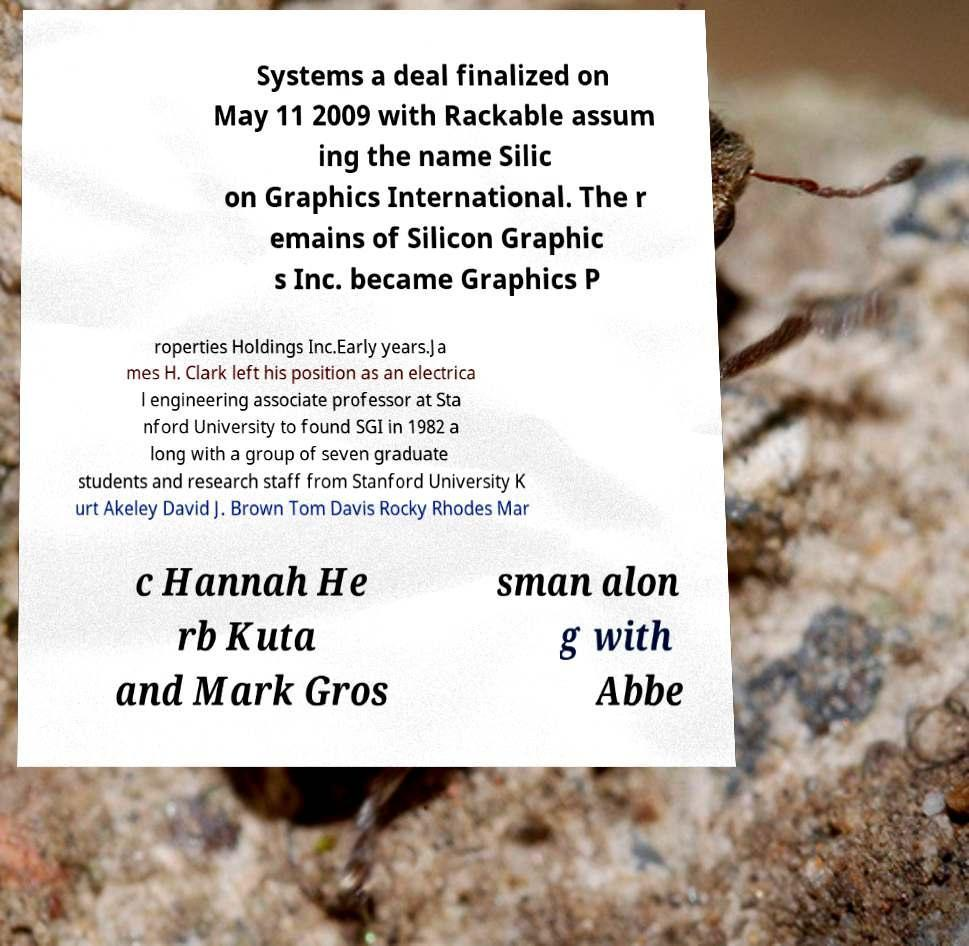Could you assist in decoding the text presented in this image and type it out clearly? Systems a deal finalized on May 11 2009 with Rackable assum ing the name Silic on Graphics International. The r emains of Silicon Graphic s Inc. became Graphics P roperties Holdings Inc.Early years.Ja mes H. Clark left his position as an electrica l engineering associate professor at Sta nford University to found SGI in 1982 a long with a group of seven graduate students and research staff from Stanford University K urt Akeley David J. Brown Tom Davis Rocky Rhodes Mar c Hannah He rb Kuta and Mark Gros sman alon g with Abbe 